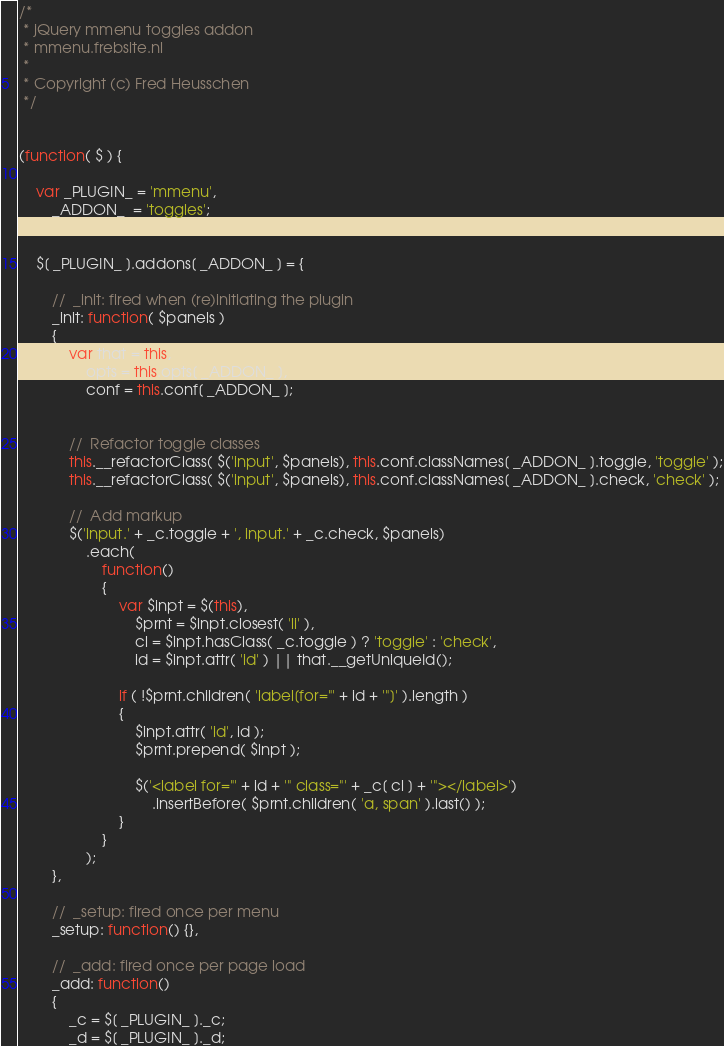Convert code to text. <code><loc_0><loc_0><loc_500><loc_500><_JavaScript_>/*	
 * jQuery mmenu toggles addon
 * mmenu.frebsite.nl
 *
 * Copyright (c) Fred Heusschen
 */


(function( $ ) {

	var _PLUGIN_ = 'mmenu',
		_ADDON_  = 'toggles';


	$[ _PLUGIN_ ].addons[ _ADDON_ ] = {
	
		//	_init: fired when (re)initiating the plugin
		_init: function( $panels )
		{			
			var that = this,
				opts = this.opts[ _ADDON_ ],
				conf = this.conf[ _ADDON_ ];
	
	
			//	Refactor toggle classes
			this.__refactorClass( $('input', $panels), this.conf.classNames[ _ADDON_ ].toggle, 'toggle' );
			this.__refactorClass( $('input', $panels), this.conf.classNames[ _ADDON_ ].check, 'check' );
	
			//	Add markup
			$('input.' + _c.toggle + ', input.' + _c.check, $panels)
				.each(
					function()
					{
						var $inpt = $(this),
							$prnt = $inpt.closest( 'li' ),
							cl = $inpt.hasClass( _c.toggle ) ? 'toggle' : 'check',
							id = $inpt.attr( 'id' ) || that.__getUniqueId();

						if ( !$prnt.children( 'label[for="' + id + '"]' ).length )
						{
							$inpt.attr( 'id', id );
							$prnt.prepend( $inpt );
	
							$('<label for="' + id + '" class="' + _c[ cl ] + '"></label>')
								.insertBefore( $prnt.children( 'a, span' ).last() );
						}
					}
				);
		},

		//	_setup: fired once per menu
		_setup: function() {},

		//	_add: fired once per page load
		_add: function()
		{
			_c = $[ _PLUGIN_ ]._c;
			_d = $[ _PLUGIN_ ]._d;</code> 